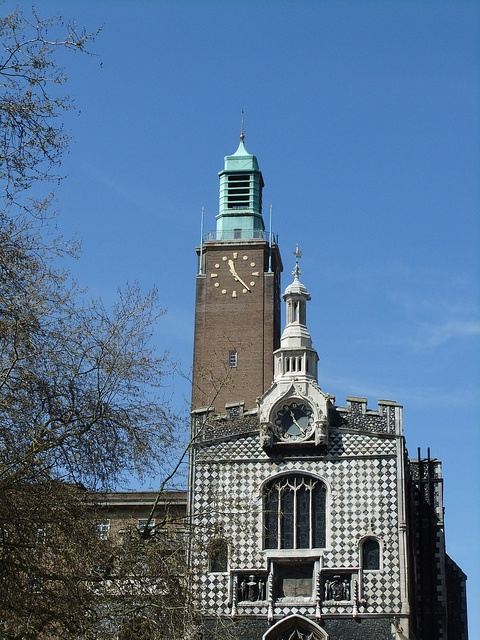Describe the objects in this image and their specific colors. I can see clock in gray and beige tones and clock in gray, black, and darkgray tones in this image. 